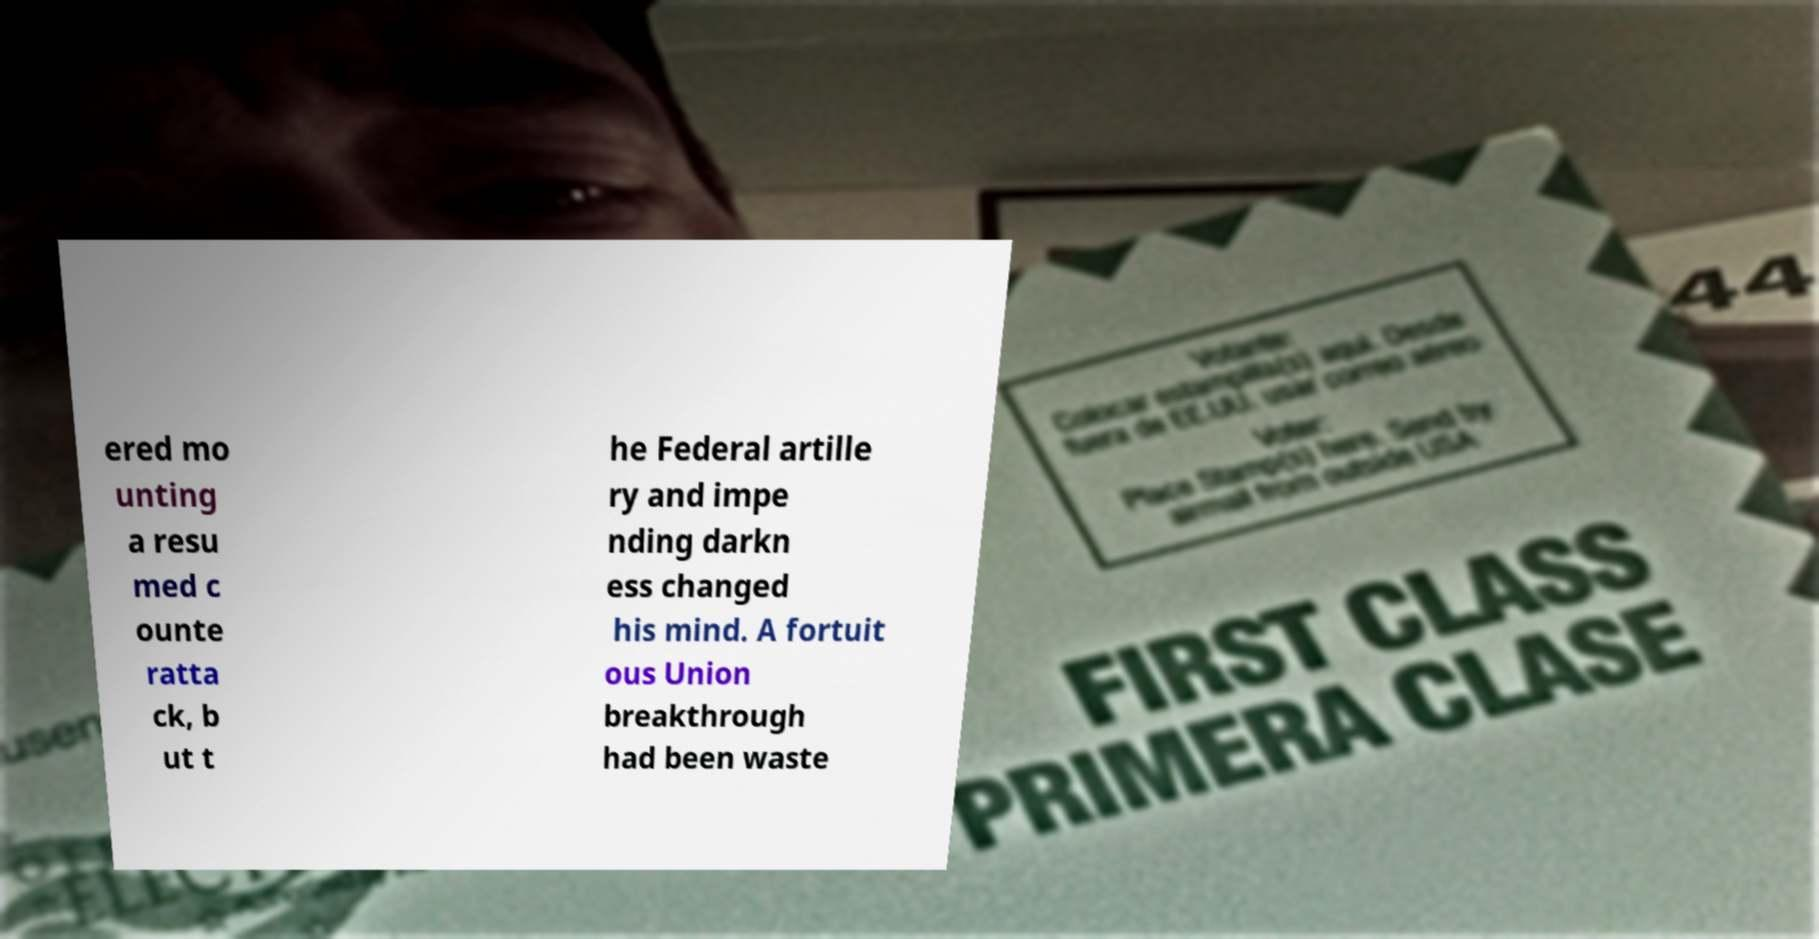For documentation purposes, I need the text within this image transcribed. Could you provide that? ered mo unting a resu med c ounte ratta ck, b ut t he Federal artille ry and impe nding darkn ess changed his mind. A fortuit ous Union breakthrough had been waste 